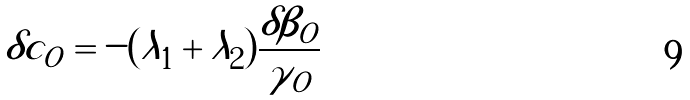Convert formula to latex. <formula><loc_0><loc_0><loc_500><loc_500>\delta c _ { O } = - ( \lambda _ { 1 } + \lambda _ { 2 } ) \frac { \delta \beta _ { O } } { \gamma _ { O } }</formula> 